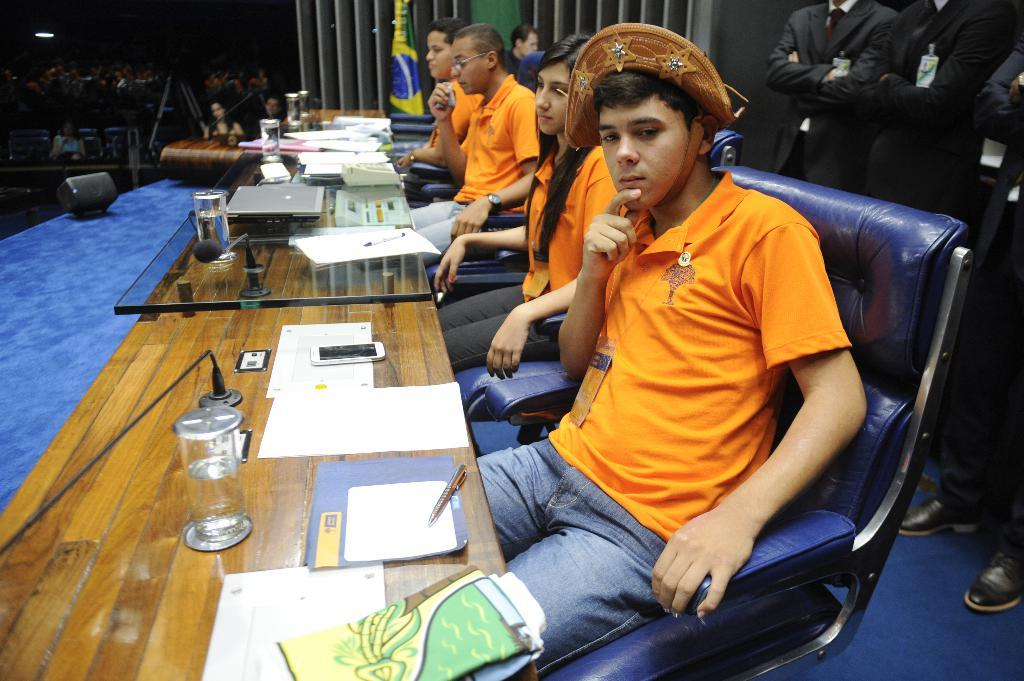What color shirts are the persons wearing in the image? The persons in the image are wearing orange shirts. What are the persons wearing orange shirts doing? They are sitting in chairs. What is in front of the seated persons? There is a table in front of the seated persons. What is on the table? There are objects on the table. Are there any other persons visible in the image? Yes, there are persons standing behind the seated persons. What type of flowers can be seen growing in the hole in the image? There is no hole or flowers present in the image. 